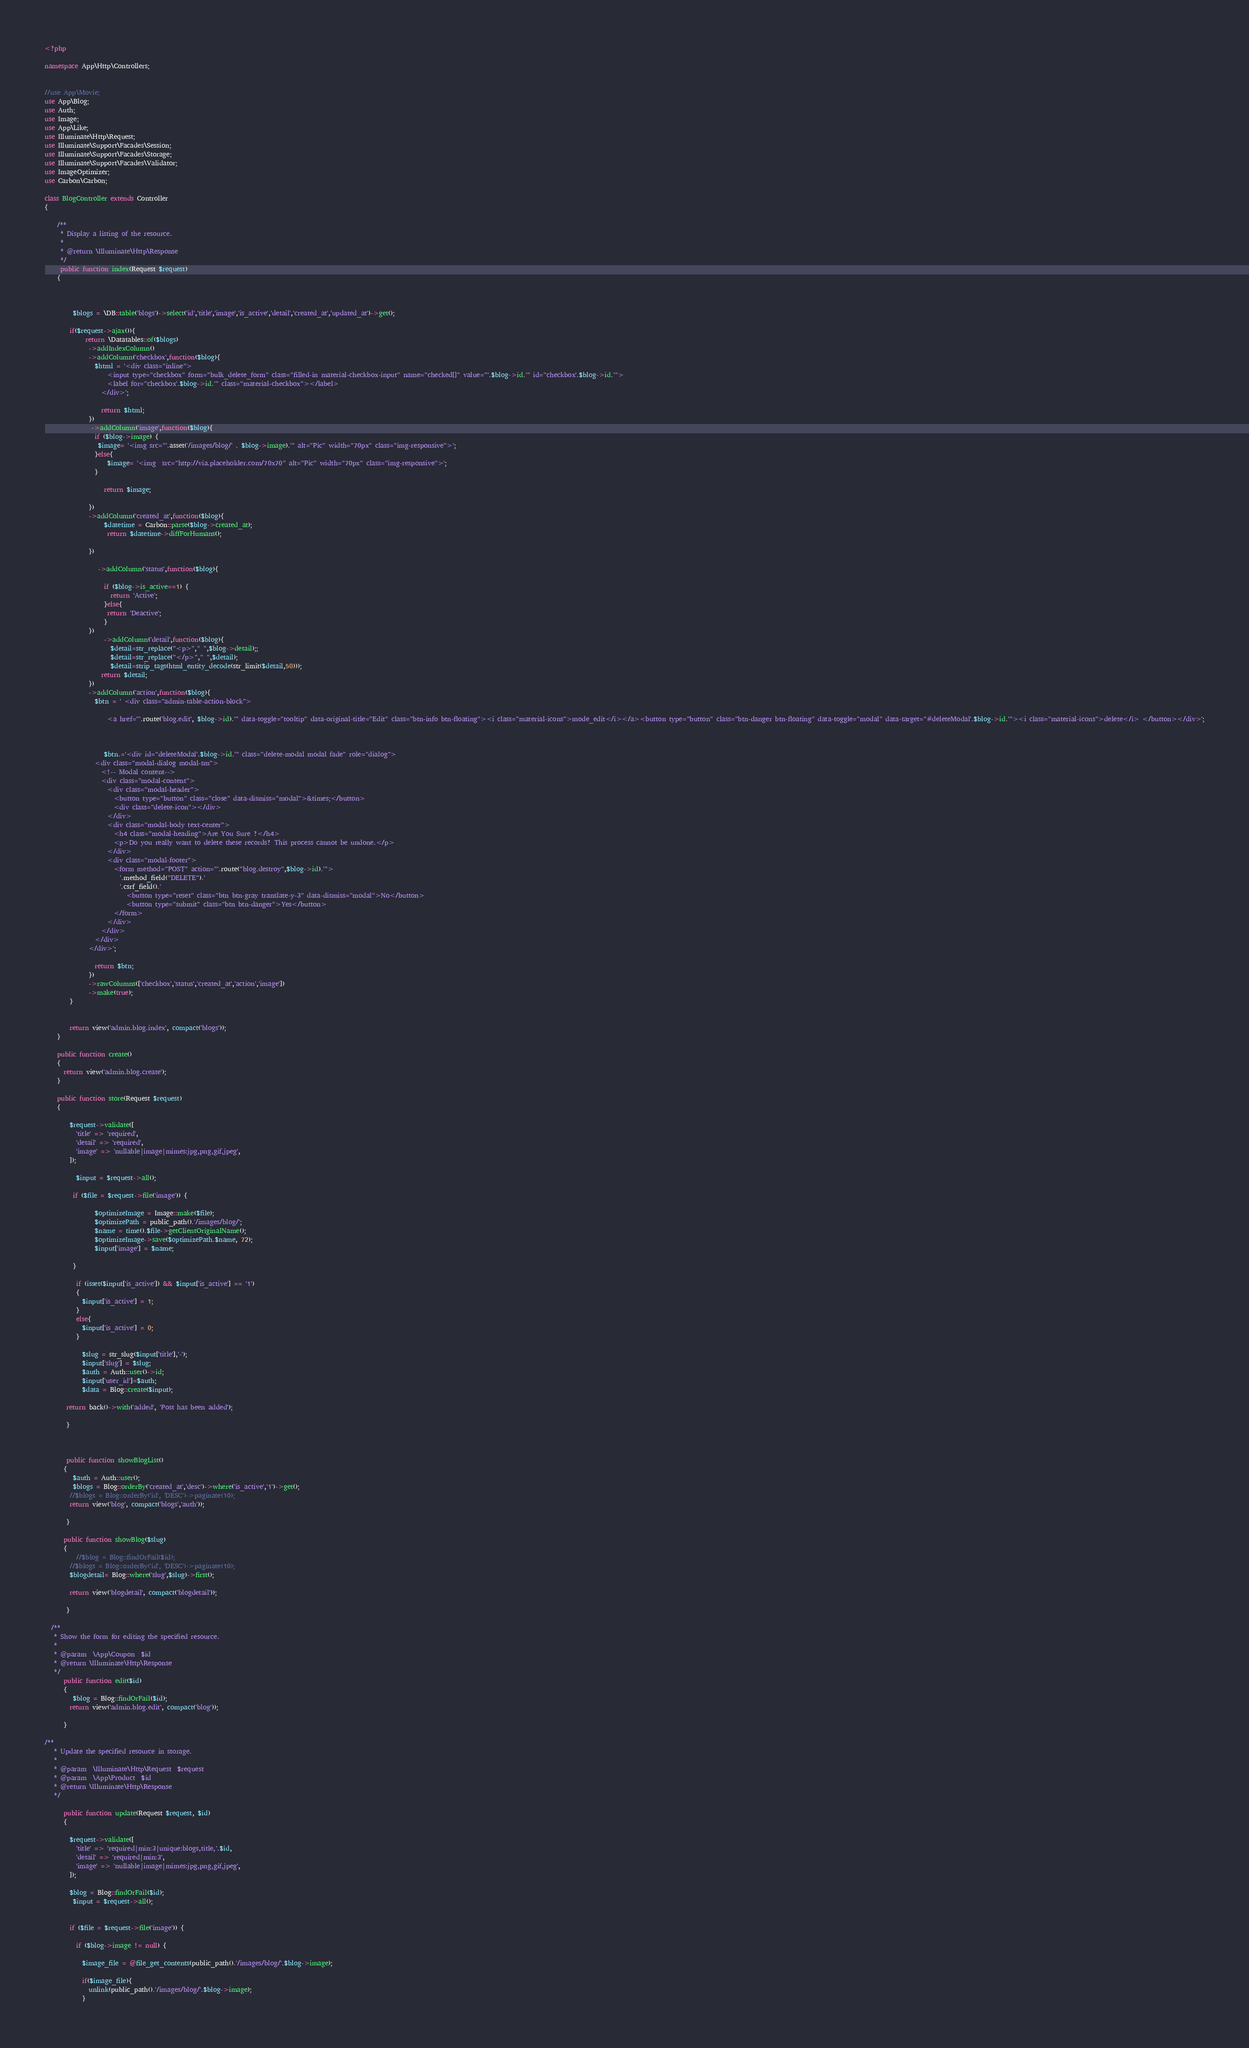<code> <loc_0><loc_0><loc_500><loc_500><_PHP_><?php

namespace App\Http\Controllers;


//use App\Movie;
use App\Blog;
use Auth;
use Image;
use App\Like;
use Illuminate\Http\Request;
use Illuminate\Support\Facades\Session;
use Illuminate\Support\Facades\Storage;
use Illuminate\Support\Facades\Validator;
use ImageOptimizer;
use Carbon\Carbon;

class BlogController extends Controller
{

    /**
     * Display a listing of the resource.
     *
     * @return \Illuminate\Http\Response
     */
     public function index(Request $request)
    {
       
        
        
         $blogs = \DB::table('blogs')->select('id','title','image','is_active','detail','created_at','updated_at')->get();

        if($request->ajax()){
             return \Datatables::of($blogs)
              ->addIndexColumn()
              ->addColumn('checkbox',function($blog){
                $html = '<div class="inline">
                    <input type="checkbox" form="bulk_delete_form" class="filled-in material-checkbox-input" name="checked[]" value="'.$blog->id.'" id="checkbox'.$blog->id.'">
                    <label for="checkbox'.$blog->id.'" class="material-checkbox"></label>
                  </div>';

                  return $html;
              })
               ->addColumn('image',function($blog){
                if ($blog->image) {
                 $image= '<img src="'.asset('/images/blog/' . $blog->image).'" alt="Pic" width="70px" class="img-responsive">';
                }else{
                    $image= '<img  src="http://via.placeholder.com/70x70" alt="Pic" width="70px" class="img-responsive">';
                }
               
                   return $image;

              })
              ->addColumn('created_at',function($blog){
                   $datetime = Carbon::parse($blog->created_at);
                    return $datetime->diffForHumans();

              })
              
                 ->addColumn('status',function($blog){
                    
                   if ($blog->is_active==1) {
                     return 'Active';
                   }else{
                    return 'Deactive';
                   }
              })
                   ->addColumn('detail',function($blog){
                     $detail=str_replace("<p>"," ",$blog->detail);;
                     $detail=str_replace("</p>"," ",$detail);
                     $detail=strip_tags(html_entity_decode(str_limit($detail,50)));
                  return $detail;
              })
              ->addColumn('action',function($blog){
                $btn = ' <div class="admin-table-action-block">
                  
                    <a href="'.route('blog.edit', $blog->id).'" data-toggle="tooltip" data-original-title="Edit" class="btn-info btn-floating"><i class="material-icons">mode_edit</i></a><button type="button" class="btn-danger btn-floating" data-toggle="modal" data-target="#deleteModal'.$blog->id.'"><i class="material-icons">delete</i> </button></div>';
                   
                   

                   $btn.='<div id="deleteModal'.$blog->id.'" class="delete-modal modal fade" role="dialog">
                <div class="modal-dialog modal-sm">
                  <!-- Modal content-->
                  <div class="modal-content">
                    <div class="modal-header">
                      <button type="button" class="close" data-dismiss="modal">&times;</button>
                      <div class="delete-icon"></div>
                    </div>
                    <div class="modal-body text-center">
                      <h4 class="modal-heading">Are You Sure ?</h4>
                      <p>Do you really want to delete these records? This process cannot be undone.</p>
                    </div>
                    <div class="modal-footer">
                      <form method="POST" action="'.route("blog.destroy",$blog->id).'">
                        '.method_field("DELETE").'
                        '.csrf_field().'
                          <button type="reset" class="btn btn-gray translate-y-3" data-dismiss="modal">No</button>
                          <button type="submit" class="btn btn-danger">Yes</button>
                      </form>
                    </div>
                  </div>
                </div>
              </div>';
                    
                return $btn;
              })
              ->rawColumns(['checkbox','status','created_at','action','image'])
              ->make(true);
        }

    
        return view('admin.blog.index', compact('blogs'));
    }

    public function create()
    {
      return view('admin.blog.create');
    }

    public function store(Request $request)
    {

        $request->validate([
          'title' => 'required',
          'detail' => 'required',
          'image' => 'nullable|image|mimes:jpg,png,gif,jpeg',
        ]);

          $input = $request->all();

         if ($file = $request->file('image')) {
      
                $optimizeImage = Image::make($file);
                $optimizePath = public_path().'/images/blog/';
                $name = time().$file->getClientOriginalName();
                $optimizeImage->save($optimizePath.$name, 72);
                $input['image'] = $name;

         }

          if (isset($input['is_active']) && $input['is_active'] == '1')
          {
            $input['is_active'] = 1;
          }
          else{
            $input['is_active'] = 0;
          }

            $slug = str_slug($input['title'],'-');
            $input['slug'] = $slug;
            $auth = Auth::user()->id;
            $input['user_id']=$auth;
            $data = Blog::create($input);

       return back()->with('added', 'Post has been added');
         
       }



       public function showBlogList()
      {
         $auth = Auth::user();
         $blogs = Blog::orderBy('created_at','desc')->where('is_active','1')->get();
        //$blogs = Blog::orderBy('id', 'DESC')->paginate(10);
        return view('blog', compact('blogs','auth'));
    
       }

      public function showBlog($slug)
      {
          //$blog = Blog::findOrFail($id);
        //$blogs = Blog::orderBy('id', 'DESC')->paginate(10);
        $blogdetail= Blog::where('slug',$slug)->first();
   
        return view('blogdetail', compact('blogdetail'));
    
       }

  /**
   * Show the form for editing the specified resource.
   *
   * @param  \App\Coupon  $id
   * @return \Illuminate\Http\Response
   */
      public function edit($id)
      {
         $blog = Blog::findOrFail($id);
        return view('admin.blog.edit', compact('blog'));
        
      }

/**
   * Update the specified resource in storage.
   *
   * @param  \Illuminate\Http\Request  $request
   * @param  \App\Product  $id
   * @return \Illuminate\Http\Response
   */

      public function update(Request $request, $id)
      {
        
        $request->validate([
          'title' => 'required|min:3|unique:blogs,title,'.$id,
          'detail' => 'required|min:3',
          'image' => 'nullable|image|mimes:jpg,png,gif,jpeg',
        ]);
        
        $blog = Blog::findOrFail($id);
         $input = $request->all();
        

        if ($file = $request->file('image')) {
          
          if ($blog->image != null) {
            
            $image_file = @file_get_contents(public_path().'/images/blog/'.$blog->image);

            if($image_file){    
              unlink(public_path().'/images/blog/'.$blog->image);
            }
</code> 